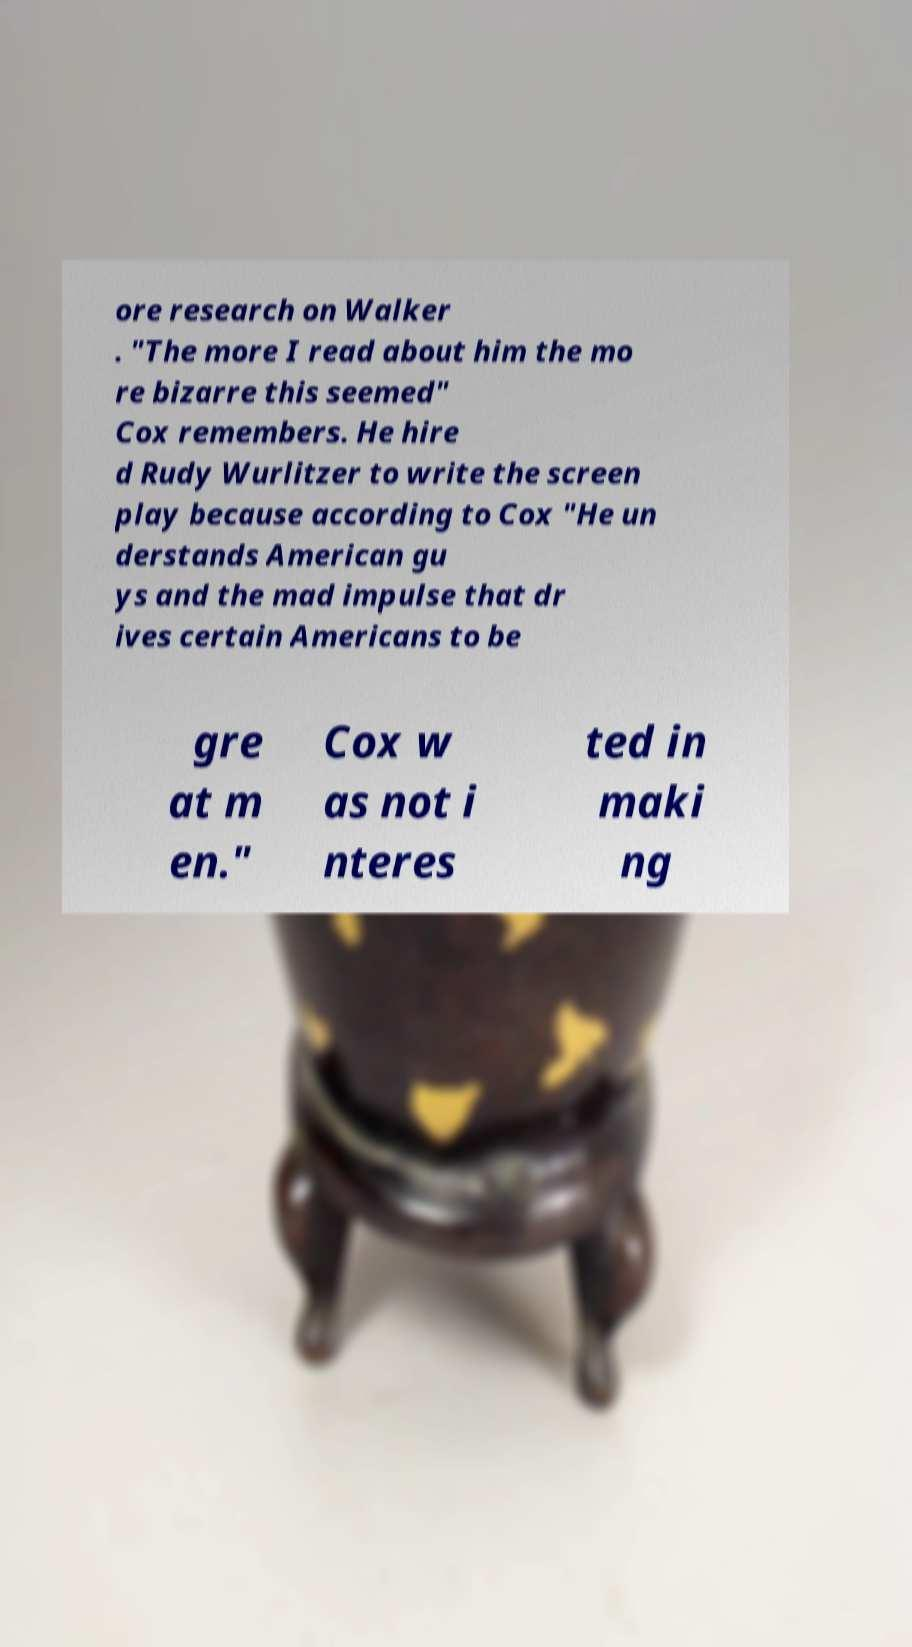I need the written content from this picture converted into text. Can you do that? ore research on Walker . "The more I read about him the mo re bizarre this seemed" Cox remembers. He hire d Rudy Wurlitzer to write the screen play because according to Cox "He un derstands American gu ys and the mad impulse that dr ives certain Americans to be gre at m en." Cox w as not i nteres ted in maki ng 